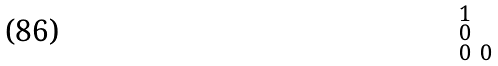<formula> <loc_0><loc_0><loc_500><loc_500>\begin{smallmatrix} 1 & & \\ 0 & & \\ 0 & 0 & \end{smallmatrix}</formula> 